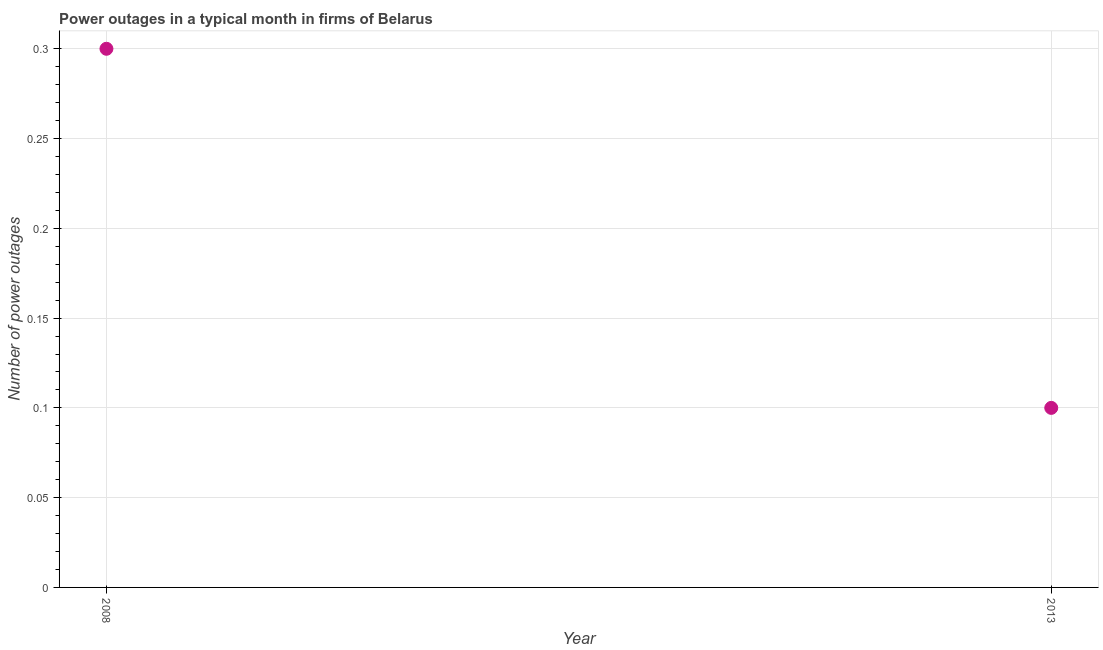In which year was the number of power outages minimum?
Your response must be concise. 2013. What is the difference between the number of power outages in 2008 and 2013?
Provide a short and direct response. 0.2. What is the average number of power outages per year?
Your response must be concise. 0.2. Do a majority of the years between 2013 and 2008 (inclusive) have number of power outages greater than 0.04 ?
Your answer should be very brief. No. What is the ratio of the number of power outages in 2008 to that in 2013?
Offer a very short reply. 3. How many dotlines are there?
Keep it short and to the point. 1. What is the difference between two consecutive major ticks on the Y-axis?
Make the answer very short. 0.05. What is the title of the graph?
Offer a very short reply. Power outages in a typical month in firms of Belarus. What is the label or title of the X-axis?
Ensure brevity in your answer.  Year. What is the label or title of the Y-axis?
Make the answer very short. Number of power outages. What is the Number of power outages in 2013?
Keep it short and to the point. 0.1. What is the difference between the Number of power outages in 2008 and 2013?
Keep it short and to the point. 0.2. 